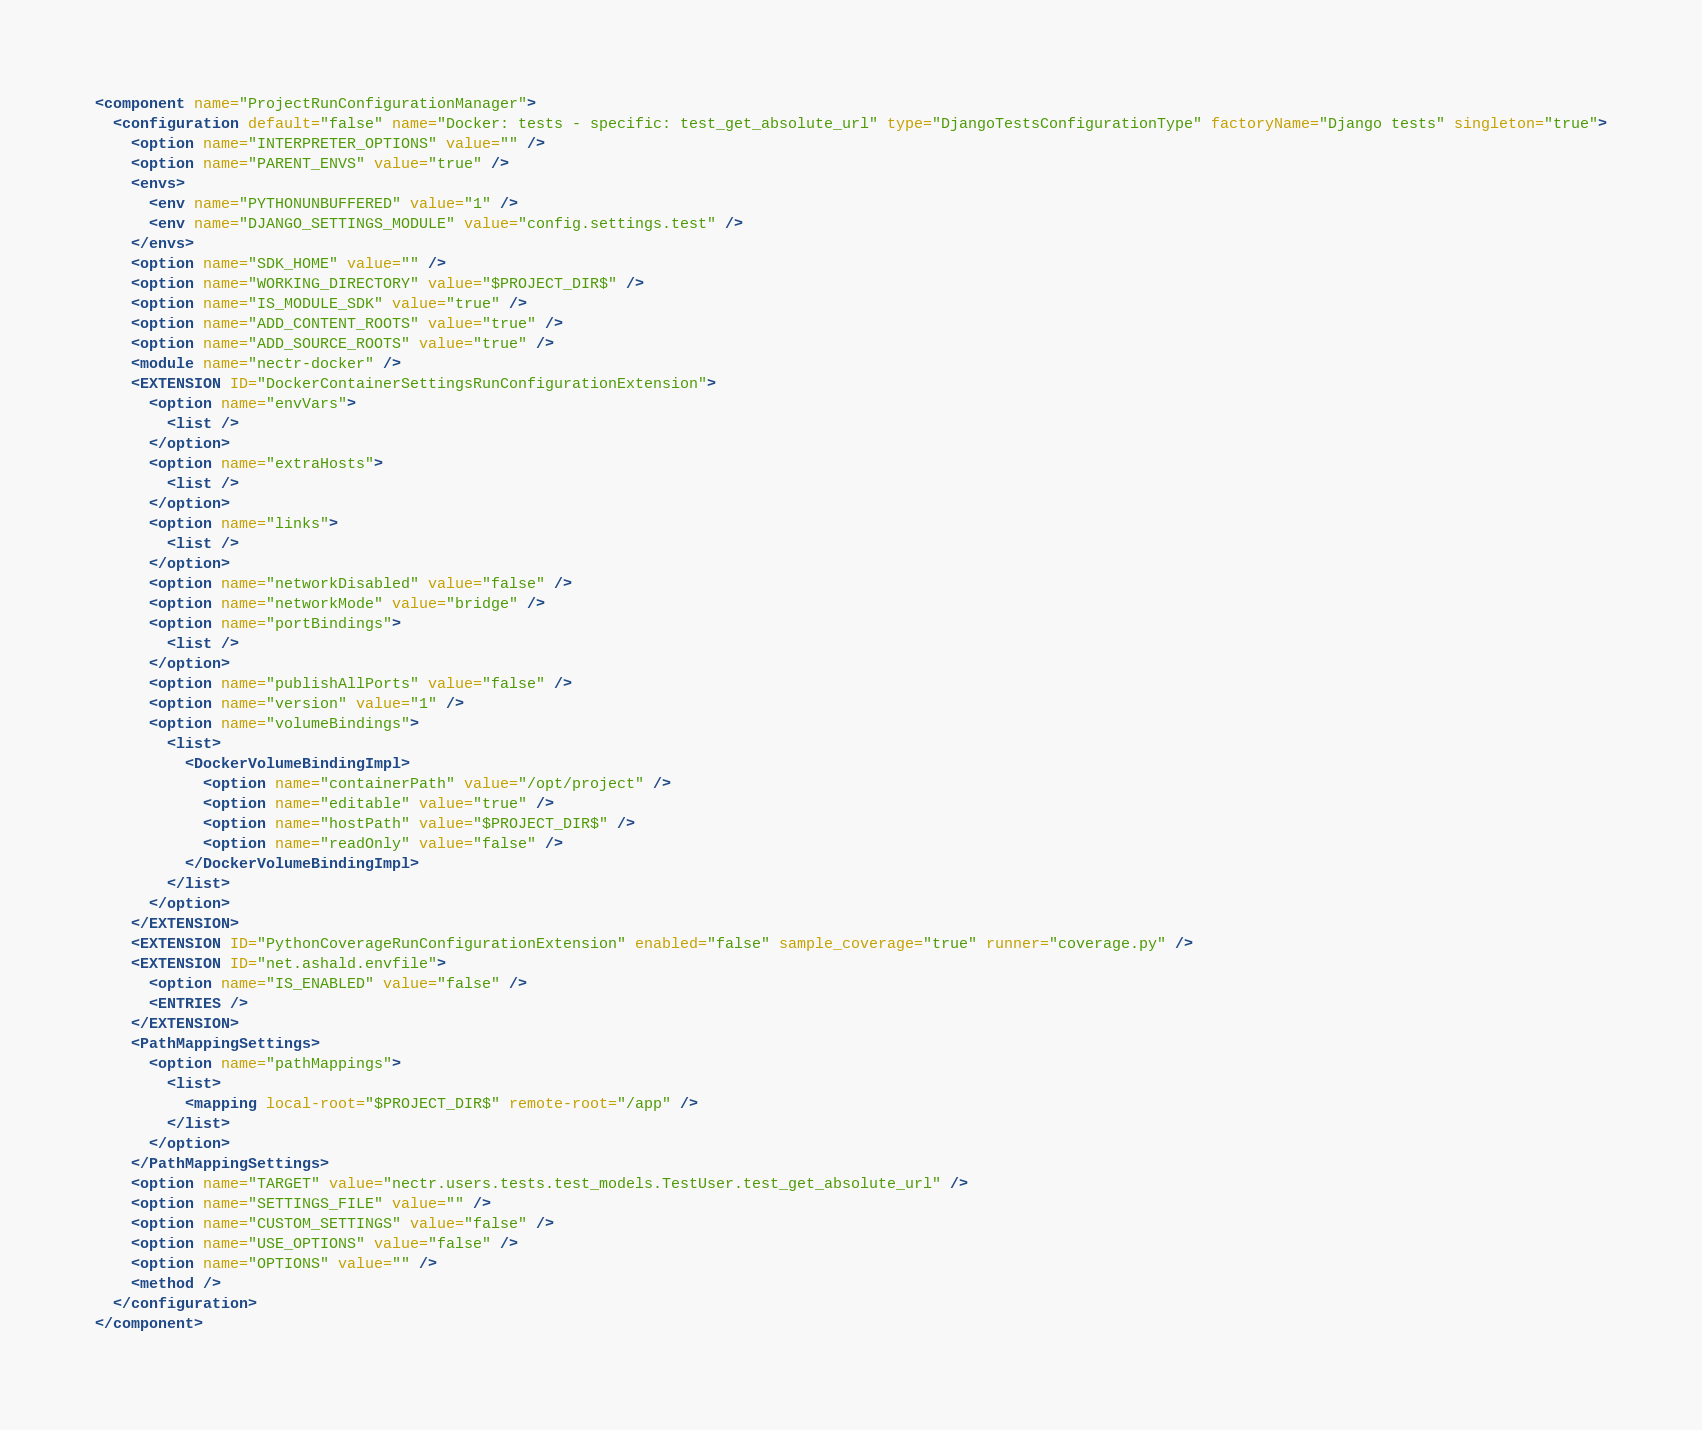Convert code to text. <code><loc_0><loc_0><loc_500><loc_500><_XML_><component name="ProjectRunConfigurationManager">
  <configuration default="false" name="Docker: tests - specific: test_get_absolute_url" type="DjangoTestsConfigurationType" factoryName="Django tests" singleton="true">
    <option name="INTERPRETER_OPTIONS" value="" />
    <option name="PARENT_ENVS" value="true" />
    <envs>
      <env name="PYTHONUNBUFFERED" value="1" />
      <env name="DJANGO_SETTINGS_MODULE" value="config.settings.test" />
    </envs>
    <option name="SDK_HOME" value="" />
    <option name="WORKING_DIRECTORY" value="$PROJECT_DIR$" />
    <option name="IS_MODULE_SDK" value="true" />
    <option name="ADD_CONTENT_ROOTS" value="true" />
    <option name="ADD_SOURCE_ROOTS" value="true" />
    <module name="nectr-docker" />
    <EXTENSION ID="DockerContainerSettingsRunConfigurationExtension">
      <option name="envVars">
        <list />
      </option>
      <option name="extraHosts">
        <list />
      </option>
      <option name="links">
        <list />
      </option>
      <option name="networkDisabled" value="false" />
      <option name="networkMode" value="bridge" />
      <option name="portBindings">
        <list />
      </option>
      <option name="publishAllPorts" value="false" />
      <option name="version" value="1" />
      <option name="volumeBindings">
        <list>
          <DockerVolumeBindingImpl>
            <option name="containerPath" value="/opt/project" />
            <option name="editable" value="true" />
            <option name="hostPath" value="$PROJECT_DIR$" />
            <option name="readOnly" value="false" />
          </DockerVolumeBindingImpl>
        </list>
      </option>
    </EXTENSION>
    <EXTENSION ID="PythonCoverageRunConfigurationExtension" enabled="false" sample_coverage="true" runner="coverage.py" />
    <EXTENSION ID="net.ashald.envfile">
      <option name="IS_ENABLED" value="false" />
      <ENTRIES />
    </EXTENSION>
    <PathMappingSettings>
      <option name="pathMappings">
        <list>
          <mapping local-root="$PROJECT_DIR$" remote-root="/app" />
        </list>
      </option>
    </PathMappingSettings>
    <option name="TARGET" value="nectr.users.tests.test_models.TestUser.test_get_absolute_url" />
    <option name="SETTINGS_FILE" value="" />
    <option name="CUSTOM_SETTINGS" value="false" />
    <option name="USE_OPTIONS" value="false" />
    <option name="OPTIONS" value="" />
    <method />
  </configuration>
</component></code> 